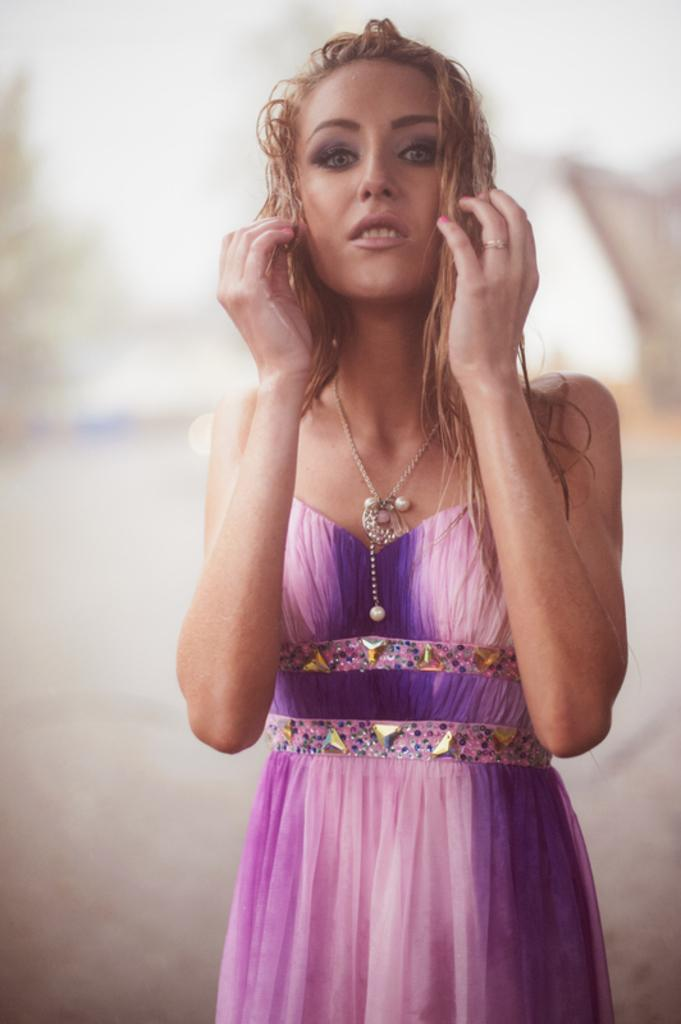What is the main subject in the image? There is a woman standing in the image. Can you describe the background of the image? The background of the image is blurred. What type of van can be seen parked next to the woman in the image? There is no van present in the image; it only features a woman standing and a blurred background. 